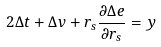Convert formula to latex. <formula><loc_0><loc_0><loc_500><loc_500>2 \Delta t + \Delta v + r _ { s } \frac { \partial \Delta e } { \partial r _ { s } } = y</formula> 